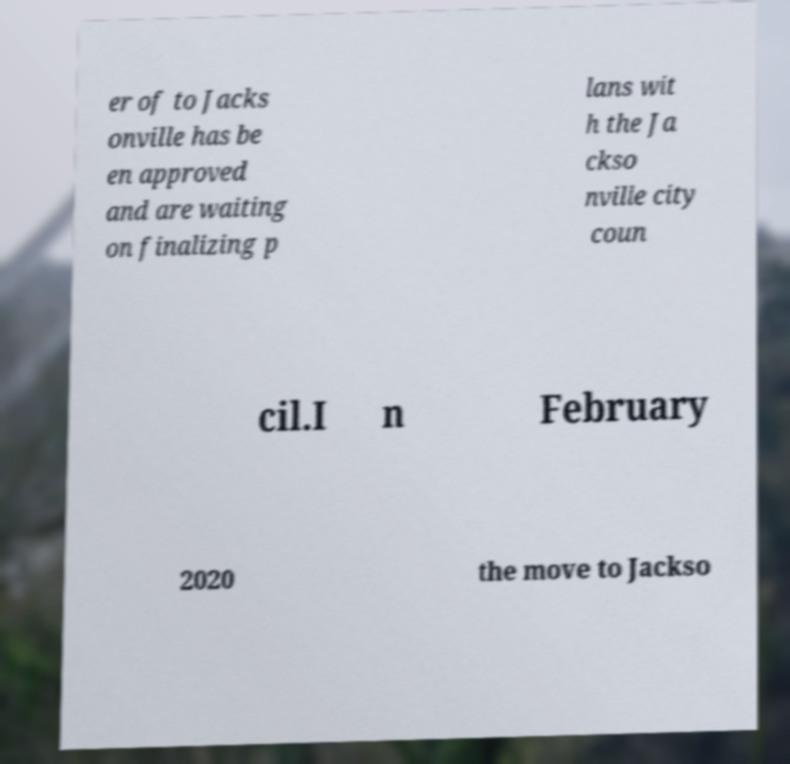Can you read and provide the text displayed in the image?This photo seems to have some interesting text. Can you extract and type it out for me? er of to Jacks onville has be en approved and are waiting on finalizing p lans wit h the Ja ckso nville city coun cil.I n February 2020 the move to Jackso 